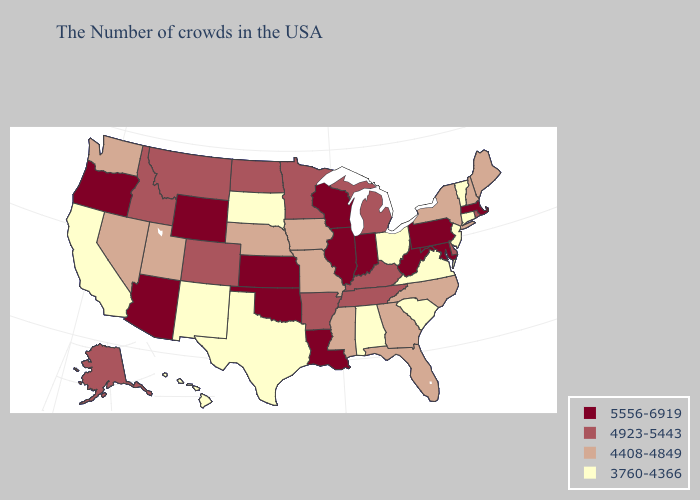What is the lowest value in states that border West Virginia?
Answer briefly. 3760-4366. Does North Carolina have the highest value in the South?
Answer briefly. No. What is the value of North Dakota?
Write a very short answer. 4923-5443. Among the states that border North Dakota , does South Dakota have the highest value?
Write a very short answer. No. Name the states that have a value in the range 3760-4366?
Short answer required. Vermont, Connecticut, New Jersey, Virginia, South Carolina, Ohio, Alabama, Texas, South Dakota, New Mexico, California, Hawaii. Does Alabama have a lower value than North Carolina?
Quick response, please. Yes. What is the value of Michigan?
Answer briefly. 4923-5443. Name the states that have a value in the range 4923-5443?
Be succinct. Rhode Island, Delaware, Michigan, Kentucky, Tennessee, Arkansas, Minnesota, North Dakota, Colorado, Montana, Idaho, Alaska. What is the value of Rhode Island?
Write a very short answer. 4923-5443. Does Pennsylvania have the highest value in the USA?
Write a very short answer. Yes. Does Colorado have the lowest value in the USA?
Give a very brief answer. No. Does Utah have the highest value in the West?
Write a very short answer. No. Does Mississippi have the highest value in the USA?
Concise answer only. No. Does Idaho have a lower value than Louisiana?
Give a very brief answer. Yes. What is the highest value in the USA?
Write a very short answer. 5556-6919. 